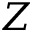<formula> <loc_0><loc_0><loc_500><loc_500>Z</formula> 